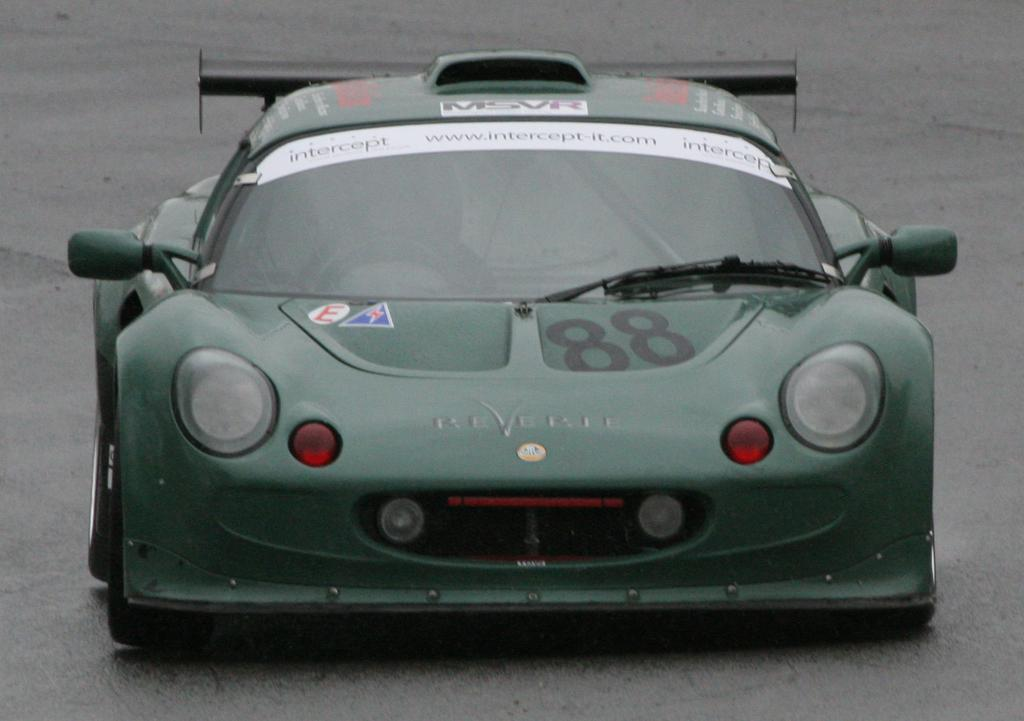What type of vehicle is in the foreground of the image? There is a sports car in the foreground of the image. Is there any specific detail about the sports car? Yes, the number "88" is written on the sports car. What can be seen in the background of the image? There is a road visible in the background of the image. What type of pie is being served on the shoe in the image? There is no pie or shoe present in the image; it features a sports car with the number "88" and a road in the background. 